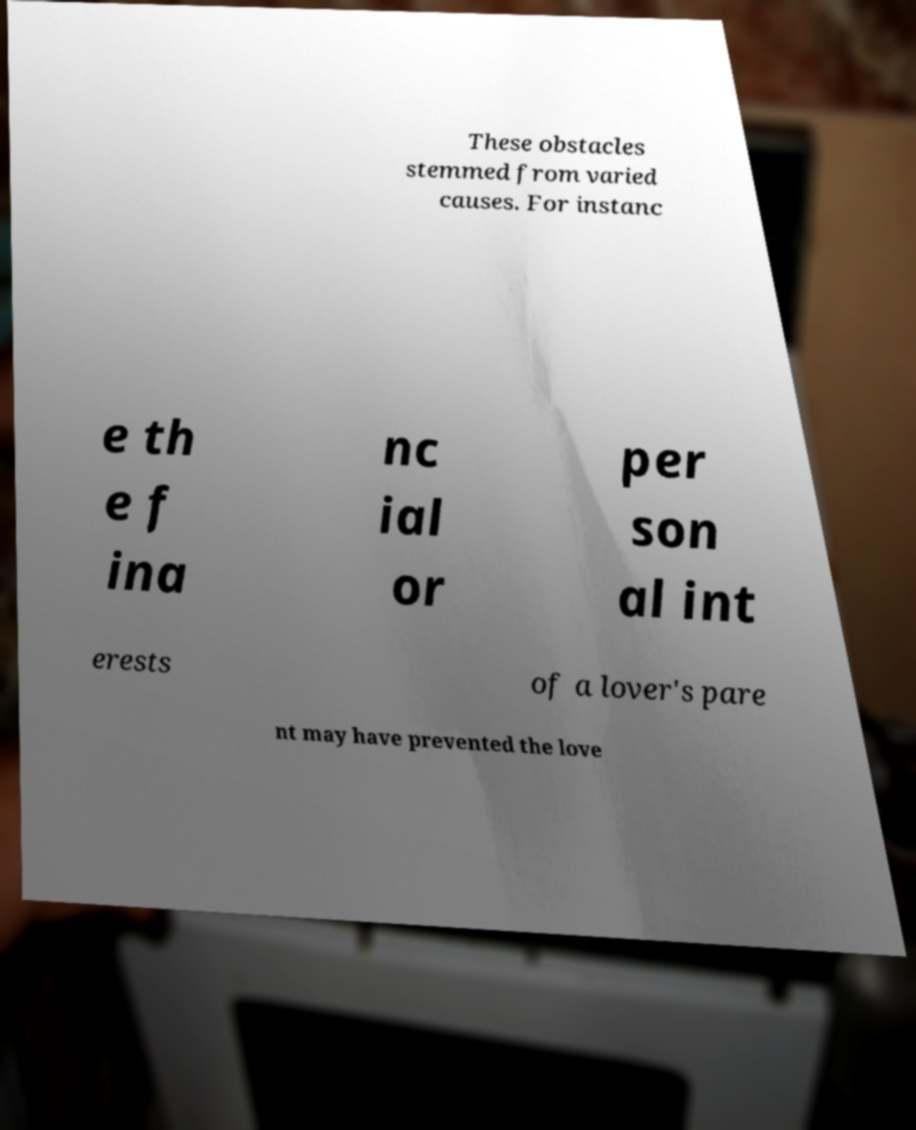Can you read and provide the text displayed in the image?This photo seems to have some interesting text. Can you extract and type it out for me? These obstacles stemmed from varied causes. For instanc e th e f ina nc ial or per son al int erests of a lover's pare nt may have prevented the love 